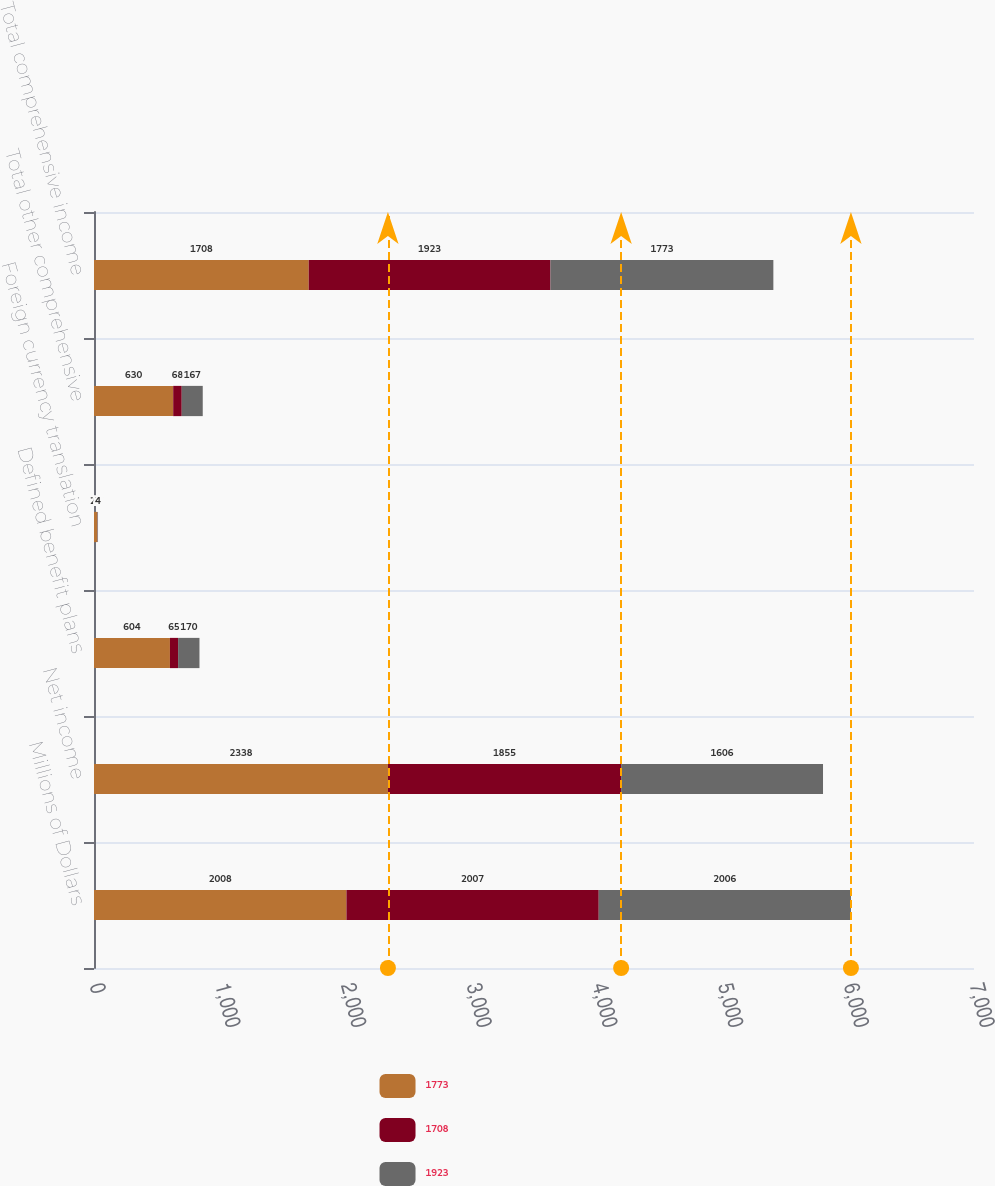<chart> <loc_0><loc_0><loc_500><loc_500><stacked_bar_chart><ecel><fcel>Millions of Dollars<fcel>Net income<fcel>Defined benefit plans<fcel>Foreign currency translation<fcel>Total other comprehensive<fcel>Total comprehensive income<nl><fcel>1773<fcel>2008<fcel>2338<fcel>604<fcel>26<fcel>630<fcel>1708<nl><fcel>1708<fcel>2007<fcel>1855<fcel>65<fcel>2<fcel>68<fcel>1923<nl><fcel>1923<fcel>2006<fcel>1606<fcel>170<fcel>4<fcel>167<fcel>1773<nl></chart> 